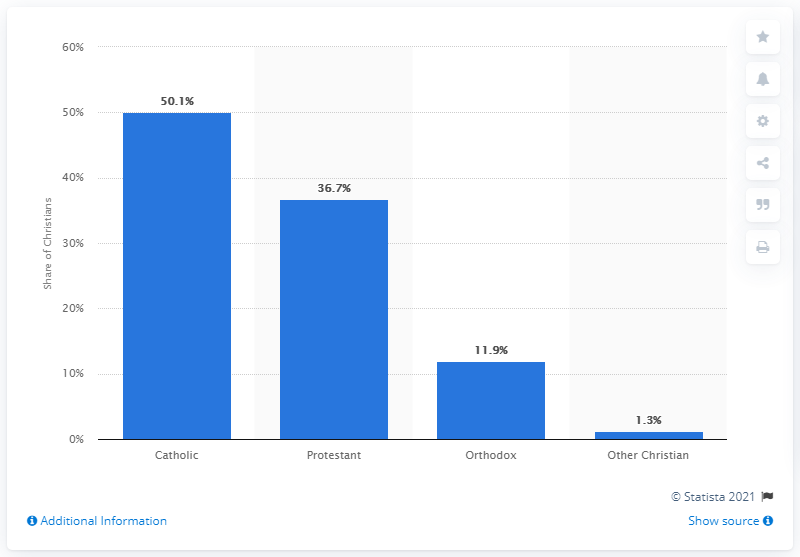Point out several critical features in this image. 50.1% of all Christians are Catholics. 